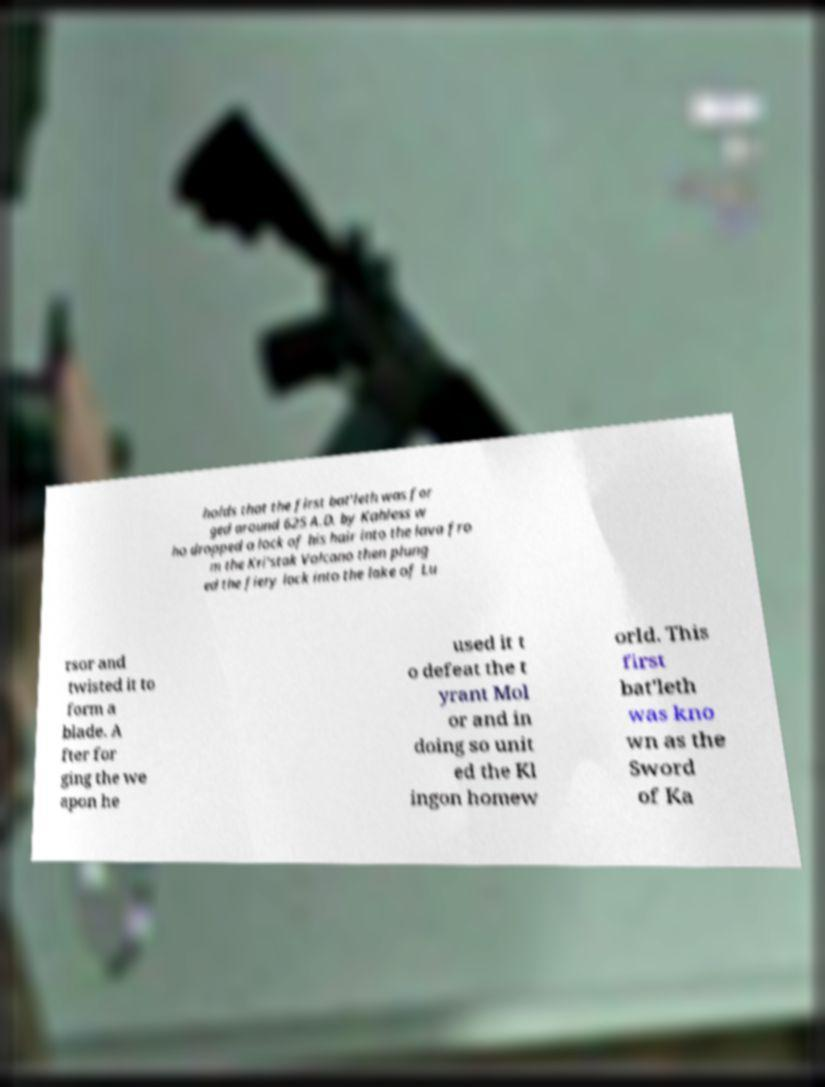Please read and relay the text visible in this image. What does it say? holds that the first bat'leth was for ged around 625 A.D. by Kahless w ho dropped a lock of his hair into the lava fro m the Kri'stak Volcano then plung ed the fiery lock into the lake of Lu rsor and twisted it to form a blade. A fter for ging the we apon he used it t o defeat the t yrant Mol or and in doing so unit ed the Kl ingon homew orld. This first bat'leth was kno wn as the Sword of Ka 